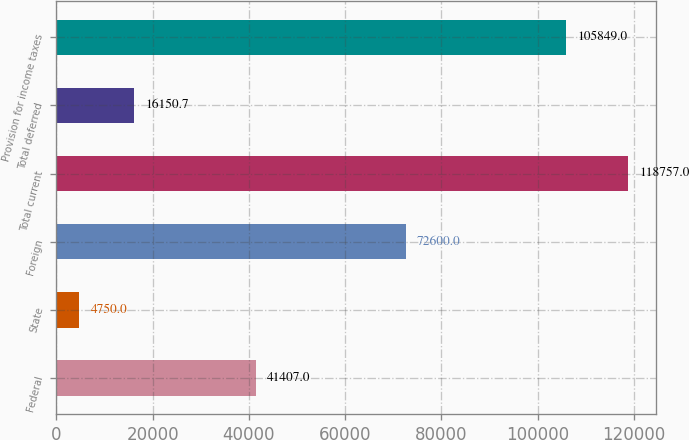Convert chart to OTSL. <chart><loc_0><loc_0><loc_500><loc_500><bar_chart><fcel>Federal<fcel>State<fcel>Foreign<fcel>Total current<fcel>Total deferred<fcel>Provision for income taxes<nl><fcel>41407<fcel>4750<fcel>72600<fcel>118757<fcel>16150.7<fcel>105849<nl></chart> 